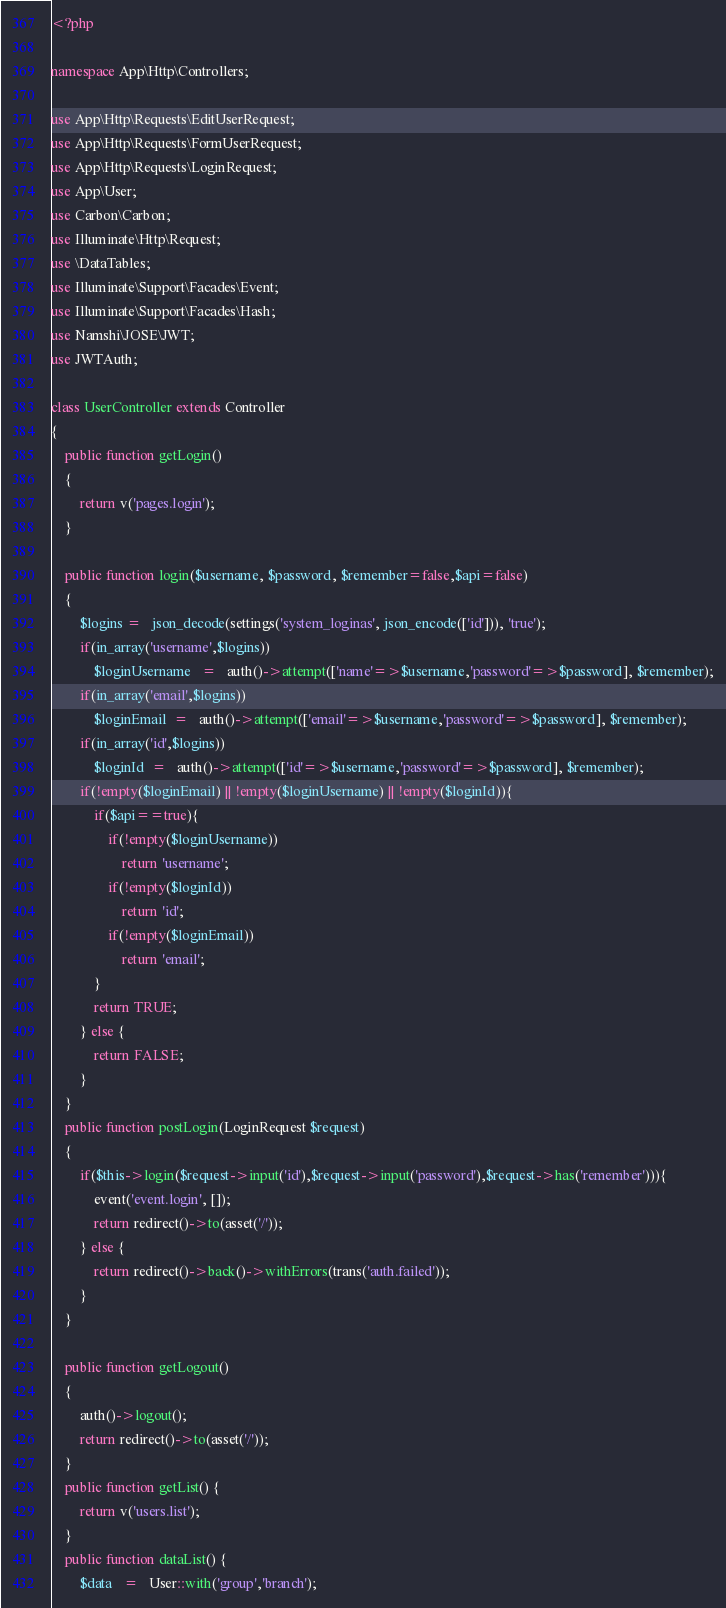Convert code to text. <code><loc_0><loc_0><loc_500><loc_500><_PHP_><?php

namespace App\Http\Controllers;

use App\Http\Requests\EditUserRequest;
use App\Http\Requests\FormUserRequest;
use App\Http\Requests\LoginRequest;
use App\User;
use Carbon\Carbon;
use Illuminate\Http\Request;
use \DataTables;
use Illuminate\Support\Facades\Event;
use Illuminate\Support\Facades\Hash;
use Namshi\JOSE\JWT;
use JWTAuth;

class UserController extends Controller
{
    public function getLogin()
    {
        return v('pages.login');
    }

    public function login($username, $password, $remember=false,$api=false)
    {
        $logins =   json_decode(settings('system_loginas', json_encode(['id'])), 'true');
        if(in_array('username',$logins))
            $loginUsername   =   auth()->attempt(['name'=>$username,'password'=>$password], $remember);
        if(in_array('email',$logins))
            $loginEmail  =   auth()->attempt(['email'=>$username,'password'=>$password], $remember);
        if(in_array('id',$logins))
            $loginId  =   auth()->attempt(['id'=>$username,'password'=>$password], $remember);
        if(!empty($loginEmail) || !empty($loginUsername) || !empty($loginId)){
            if($api==true){
                if(!empty($loginUsername))
                    return 'username';
                if(!empty($loginId))
                    return 'id';
                if(!empty($loginEmail))
                    return 'email';
            }
            return TRUE;
        } else {
            return FALSE;
        }
    }
    public function postLogin(LoginRequest $request)
    {
        if($this->login($request->input('id'),$request->input('password'),$request->has('remember'))){
            event('event.login', []);
            return redirect()->to(asset('/'));
        } else {
            return redirect()->back()->withErrors(trans('auth.failed'));
        }
    }

    public function getLogout()
    {
        auth()->logout();
        return redirect()->to(asset('/'));
    }
    public function getList() {
        return v('users.list');
    }
    public function dataList() {
        $data   =   User::with('group','branch');
</code> 